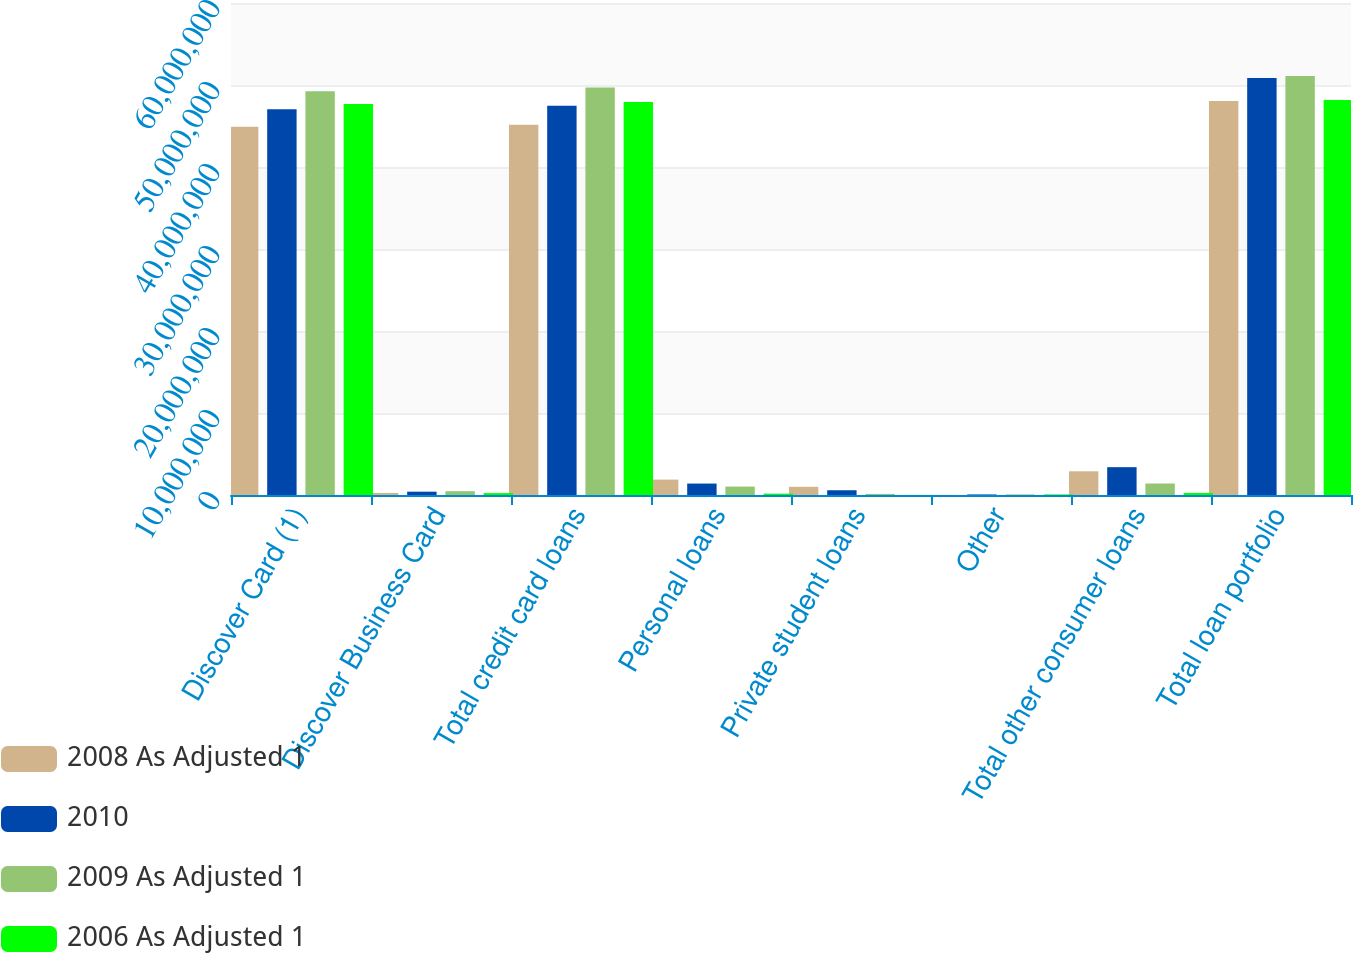<chart> <loc_0><loc_0><loc_500><loc_500><stacked_bar_chart><ecel><fcel>Discover Card (1)<fcel>Discover Business Card<fcel>Total credit card loans<fcel>Personal loans<fcel>Private student loans<fcel>Other<fcel>Total other consumer loans<fcel>Total loan portfolio<nl><fcel>2008 As Adjusted 1<fcel>4.49043e+07<fcel>252727<fcel>4.5157e+07<fcel>1.87763e+06<fcel>999322<fcel>14363<fcel>2.89132e+06<fcel>4.80483e+07<nl><fcel>2010<fcel>4.70552e+07<fcel>404149<fcel>4.74594e+07<fcel>1.39438e+06<fcel>579679<fcel>68137<fcel>3.39478e+06<fcel>5.08541e+07<nl><fcel>2009 As Adjusted 1<fcel>4.92268e+07<fcel>466173<fcel>4.9693e+07<fcel>1.02809e+06<fcel>132180<fcel>74282<fcel>1.4023e+06<fcel>5.10953e+07<nl><fcel>2006 As Adjusted 1<fcel>4.76951e+07<fcel>234136<fcel>4.79292e+07<fcel>165529<fcel>8440<fcel>72845<fcel>251194<fcel>4.81804e+07<nl></chart> 